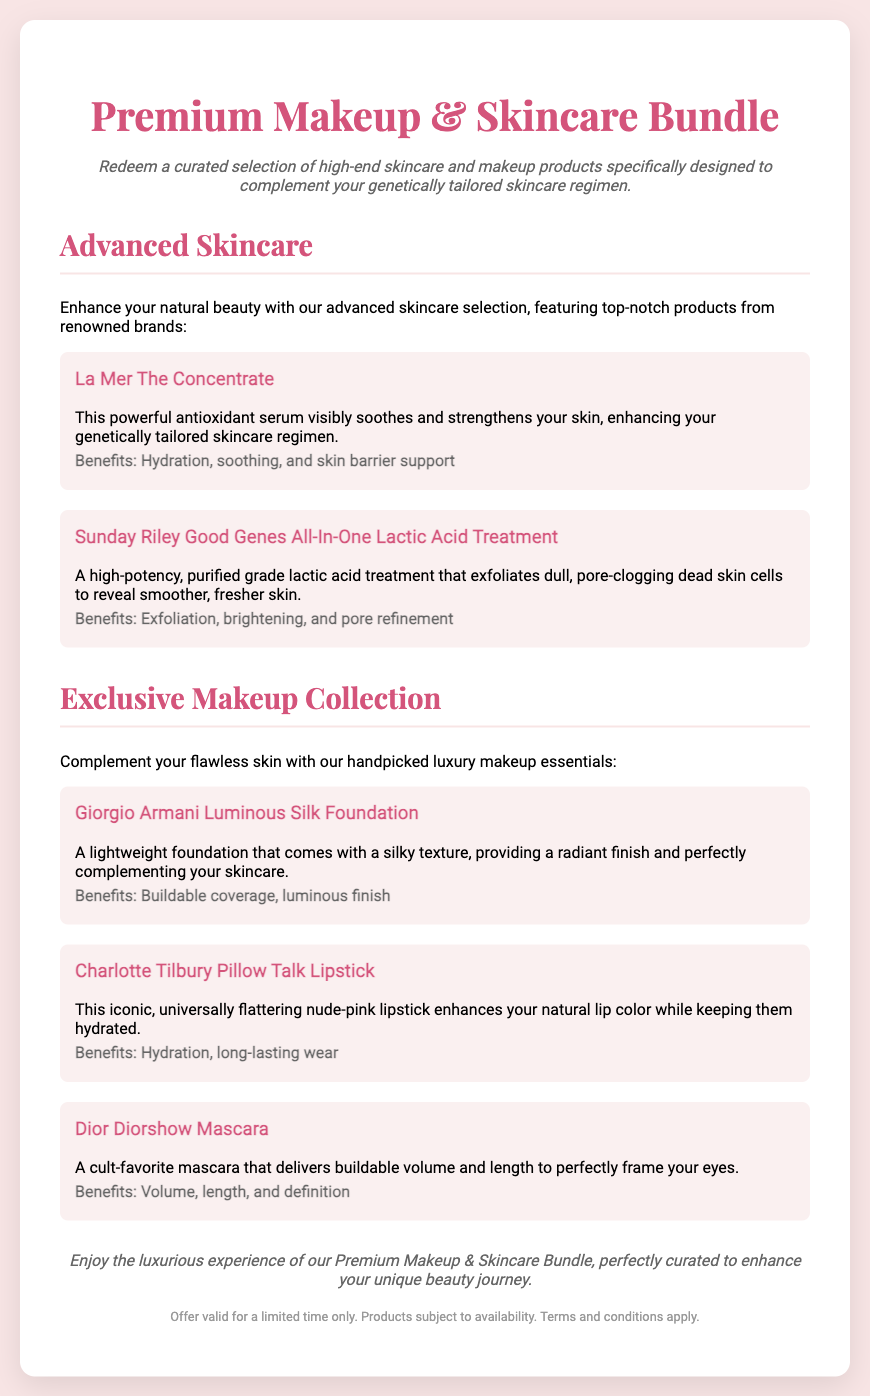What is the title of the voucher? The title of the voucher is the main heading displayed at the top of the document.
Answer: Premium Makeup & Skincare Bundle What brand is "The Concentrate" from? "The Concentrate" is a product mentioned in the advanced skincare section of the document.
Answer: La Mer What is the benefit of the "Good Genes All-In-One Lactic Acid Treatment"? The benefits of the "Good Genes All-In-One Lactic Acid Treatment" are listed in the document.
Answer: Exfoliation, brightening, and pore refinement What is the main purpose of the gift voucher? The subheadline clarifies the main purpose of the voucher.
Answer: Complement your genetically tailored skincare regimen How many products are listed under the Exclusive Makeup Collection? The number of products in the Exclusive Makeup Collection can be counted from the document.
Answer: Three What is the texture of the Giorgio Armani Luminous Silk Foundation? The texture of the Giorgio Armani Luminous Silk Foundation is described in the document.
Answer: Silky texture Is the voucher offer valid for a limited time? The document provides details about the validity of the voucher offer.
Answer: Yes What is the color of the Charlotte Tilbury Pillow Talk Lipstick? The color of the Charlotte Tilbury Pillow Talk Lipstick is specified in the product description.
Answer: Nude-pink What type of products does the voucher include? The document specifies the types of products available with the gift voucher.
Answer: High-end skincare and makeup products 